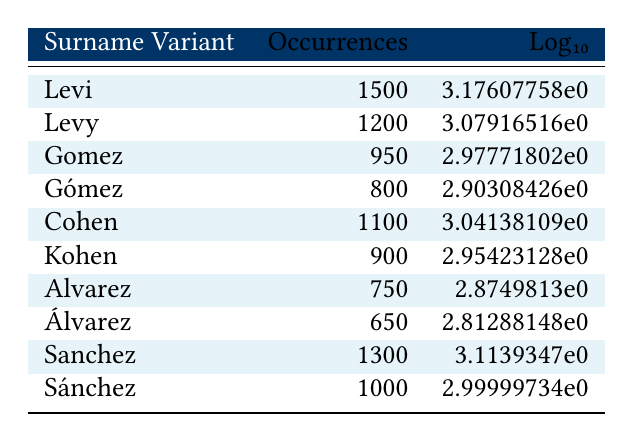What is the occurrence of the surname variant "Levi"? The table shows that the occurrence of the surname variant "Levi" is listed under the occurrences column. It reads as 1500.
Answer: 1500 Which surname variant has the highest occurrence? By examining the occurrences column, the highest value is 1500, corresponding to the surname variant "Levi".
Answer: Levi What is the sum of the occurrences of "Sanchez" and "Sánchez"? The table shows the occurrences for each: "Sanchez" is 1300 and "Sánchez" is 1000. Adding these two values gives 1300 + 1000 = 2300.
Answer: 2300 Is the occurrence of "Álvarez" greater than "Kohen"? Comparing the two values, "Álvarez" has 650 occurrences and "Kohen" has 900 occurrences. Since 650 is less than 900, the answer is no.
Answer: No What is the average occurrence of the surname variants "Cohen", "Levy", and "Gomez"? First, we find the occurrences of these variants: "Cohen" is 1100, "Levy" is 1200, and "Gomez" is 950. The sum is 1100 + 1200 + 950 = 3350. Then, dividing this sum by 3 (the number of variants) gives an average of 3350 / 3 = approximately 1116.67.
Answer: 1116.67 Which surname variant has the lowest occurrence? Analyzing the occurrences listed, "Álvarez" with 650 has the lowest number compared to the other variants in the table.
Answer: Álvarez What is the logarithmic value of the occurrences for "Gómez"? The occurrence for "Gómez" is 800. Taking the logarithm base 10, log10(800) gives approximately 2.90 when calculated.
Answer: 2.90 Do "Levy" and "Cohen" have occurrences that differ by less than 300? The occurrences are 1200 for "Levy" and 1100 for "Cohen". The difference is 1200 - 1100 = 100, which is less than 300. Therefore, the answer is yes.
Answer: Yes What is the difference in occurrences between the surname variants "Sanchez" and "Gomez"? The occurrences are 1300 for "Sanchez" and 950 for "Gomez". To find the difference, we calculate 1300 - 950 = 350.
Answer: 350 